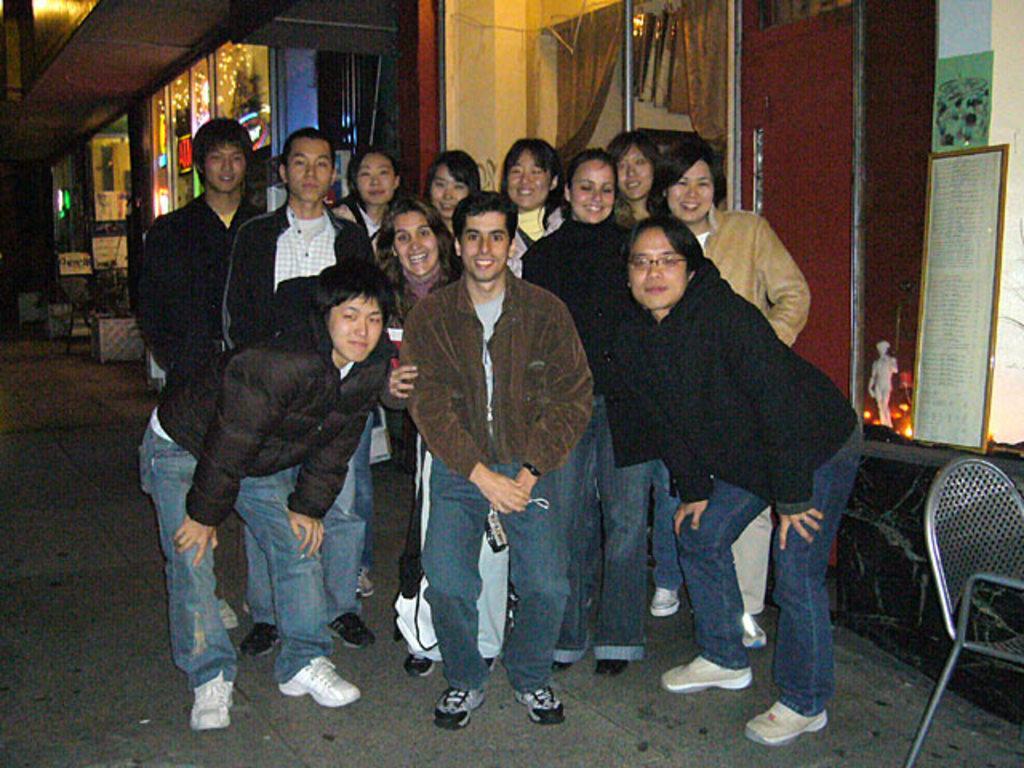Describe this image in one or two sentences. In this image we can see a group of people are standing and smiling, there a person is wearing the jacket, there is the chair on the ground, there is the light. 